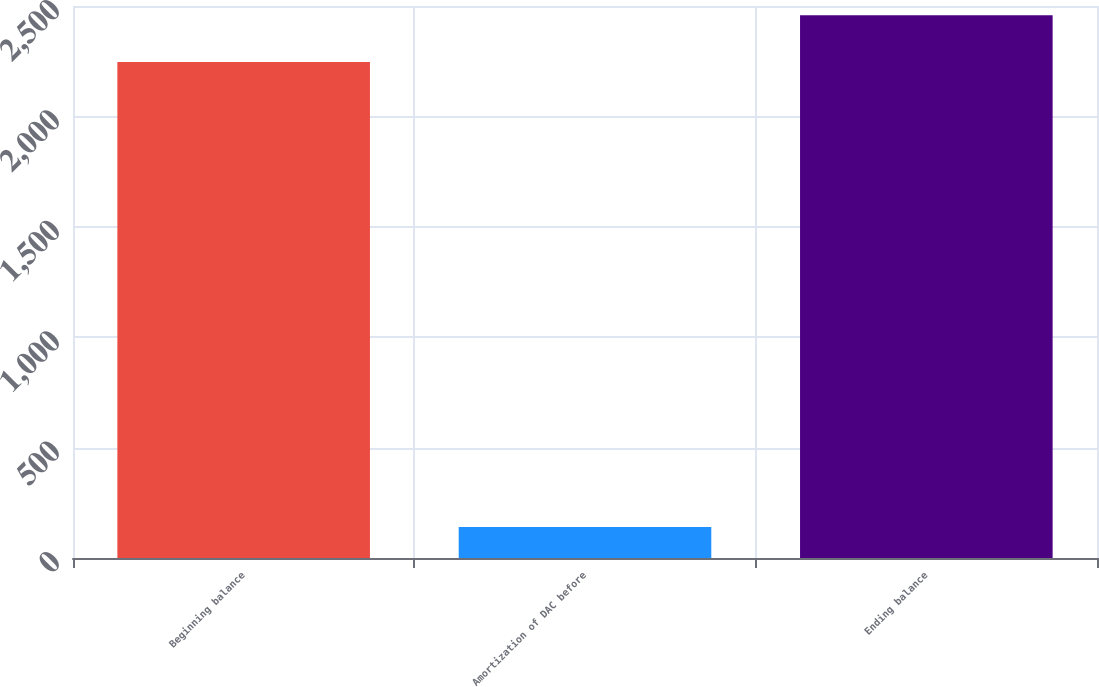<chart> <loc_0><loc_0><loc_500><loc_500><bar_chart><fcel>Beginning balance<fcel>Amortization of DAC before<fcel>Ending balance<nl><fcel>2246<fcel>140<fcel>2458.5<nl></chart> 